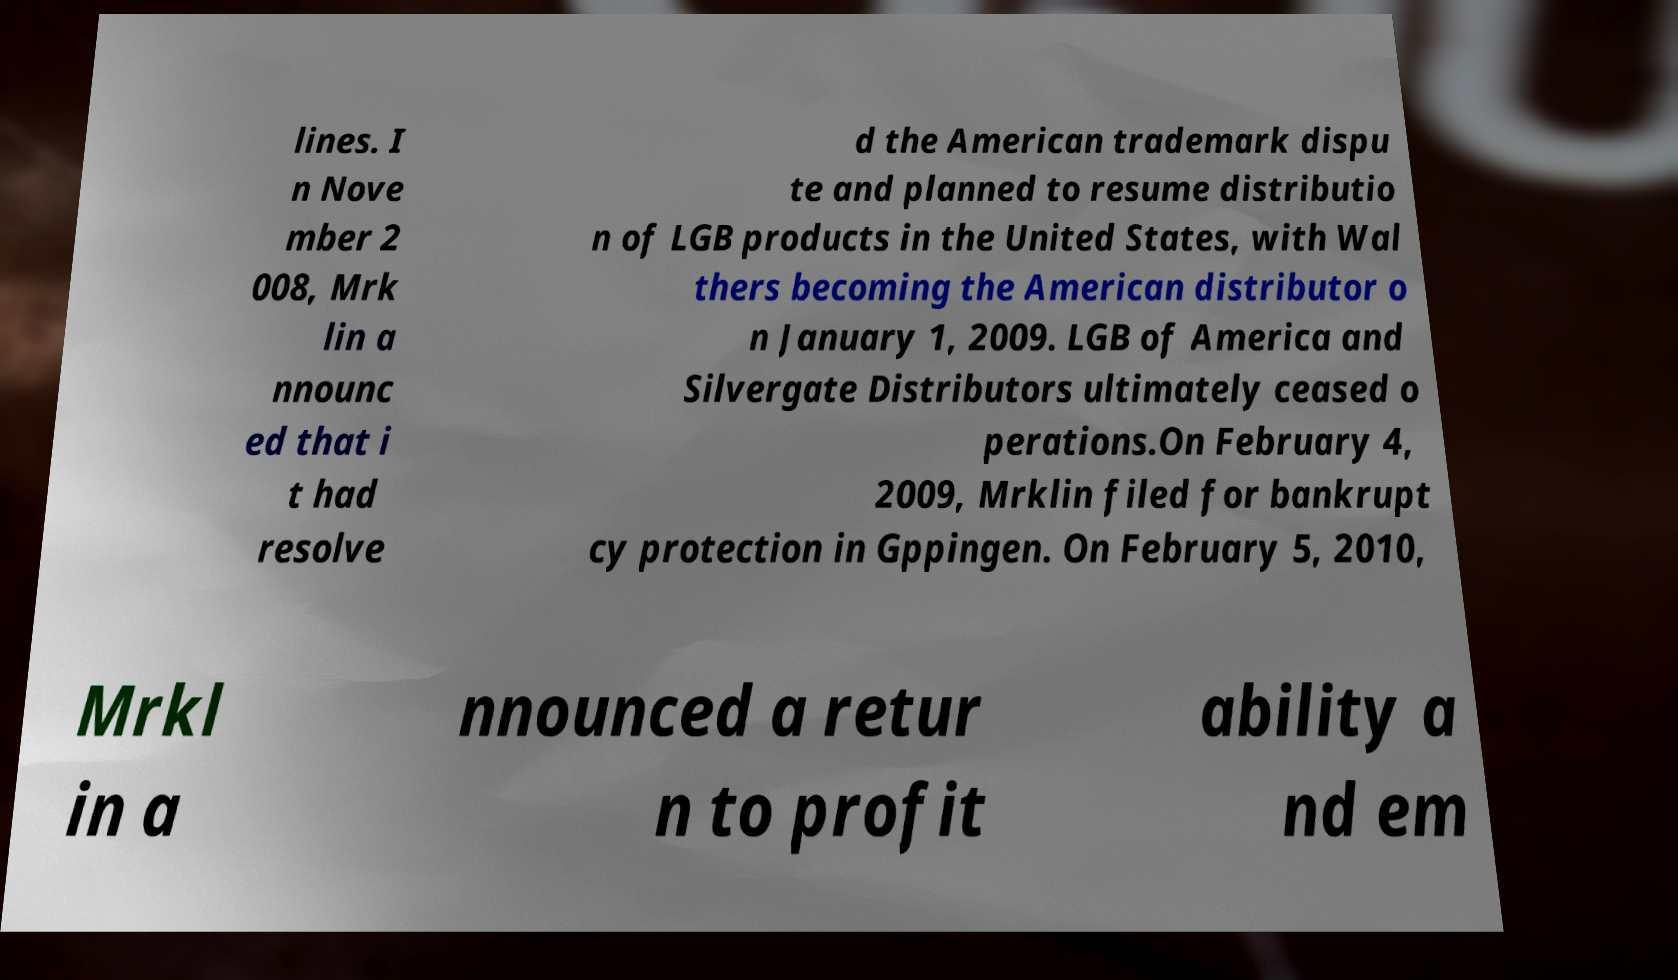There's text embedded in this image that I need extracted. Can you transcribe it verbatim? lines. I n Nove mber 2 008, Mrk lin a nnounc ed that i t had resolve d the American trademark dispu te and planned to resume distributio n of LGB products in the United States, with Wal thers becoming the American distributor o n January 1, 2009. LGB of America and Silvergate Distributors ultimately ceased o perations.On February 4, 2009, Mrklin filed for bankrupt cy protection in Gppingen. On February 5, 2010, Mrkl in a nnounced a retur n to profit ability a nd em 